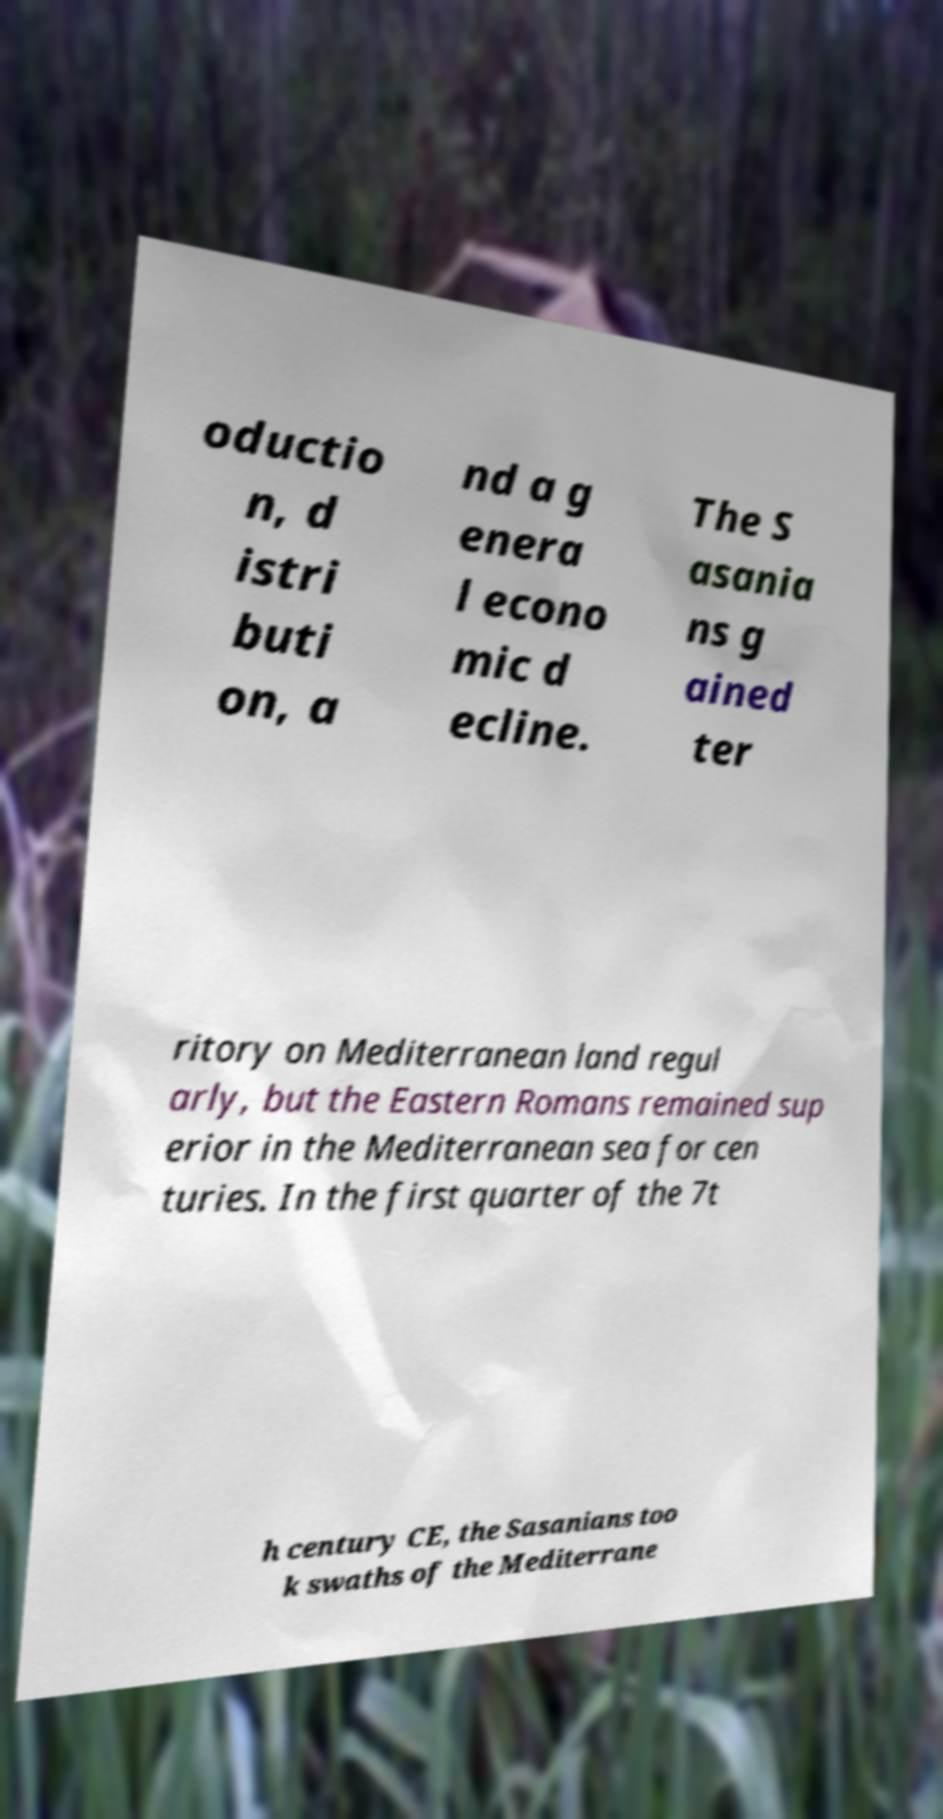For documentation purposes, I need the text within this image transcribed. Could you provide that? oductio n, d istri buti on, a nd a g enera l econo mic d ecline. The S asania ns g ained ter ritory on Mediterranean land regul arly, but the Eastern Romans remained sup erior in the Mediterranean sea for cen turies. In the first quarter of the 7t h century CE, the Sasanians too k swaths of the Mediterrane 